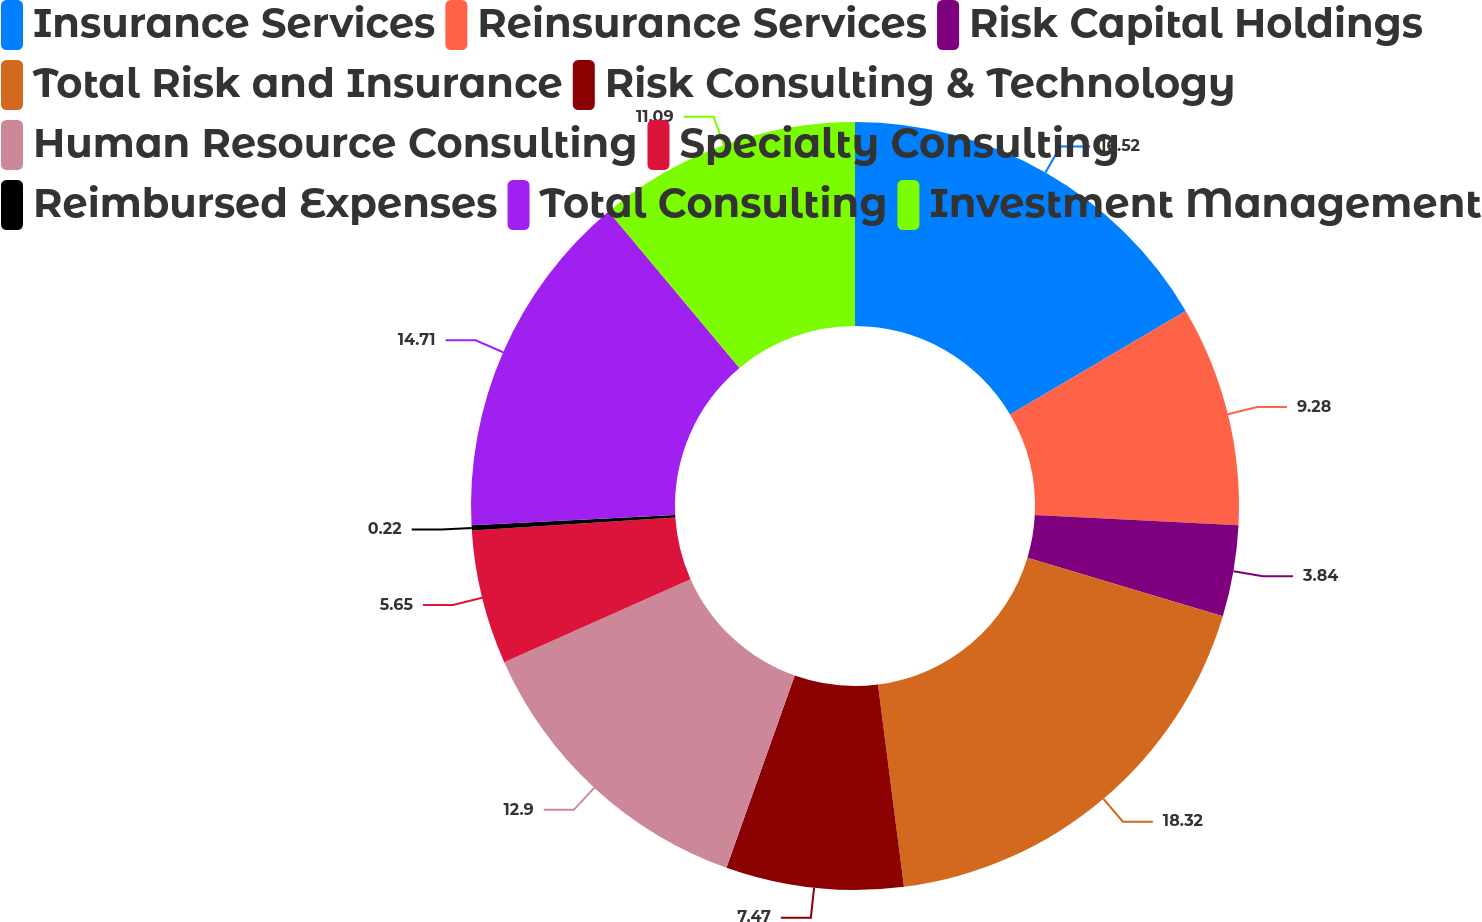Convert chart to OTSL. <chart><loc_0><loc_0><loc_500><loc_500><pie_chart><fcel>Insurance Services<fcel>Reinsurance Services<fcel>Risk Capital Holdings<fcel>Total Risk and Insurance<fcel>Risk Consulting & Technology<fcel>Human Resource Consulting<fcel>Specialty Consulting<fcel>Reimbursed Expenses<fcel>Total Consulting<fcel>Investment Management<nl><fcel>16.52%<fcel>9.28%<fcel>3.84%<fcel>18.33%<fcel>7.47%<fcel>12.9%<fcel>5.65%<fcel>0.22%<fcel>14.71%<fcel>11.09%<nl></chart> 